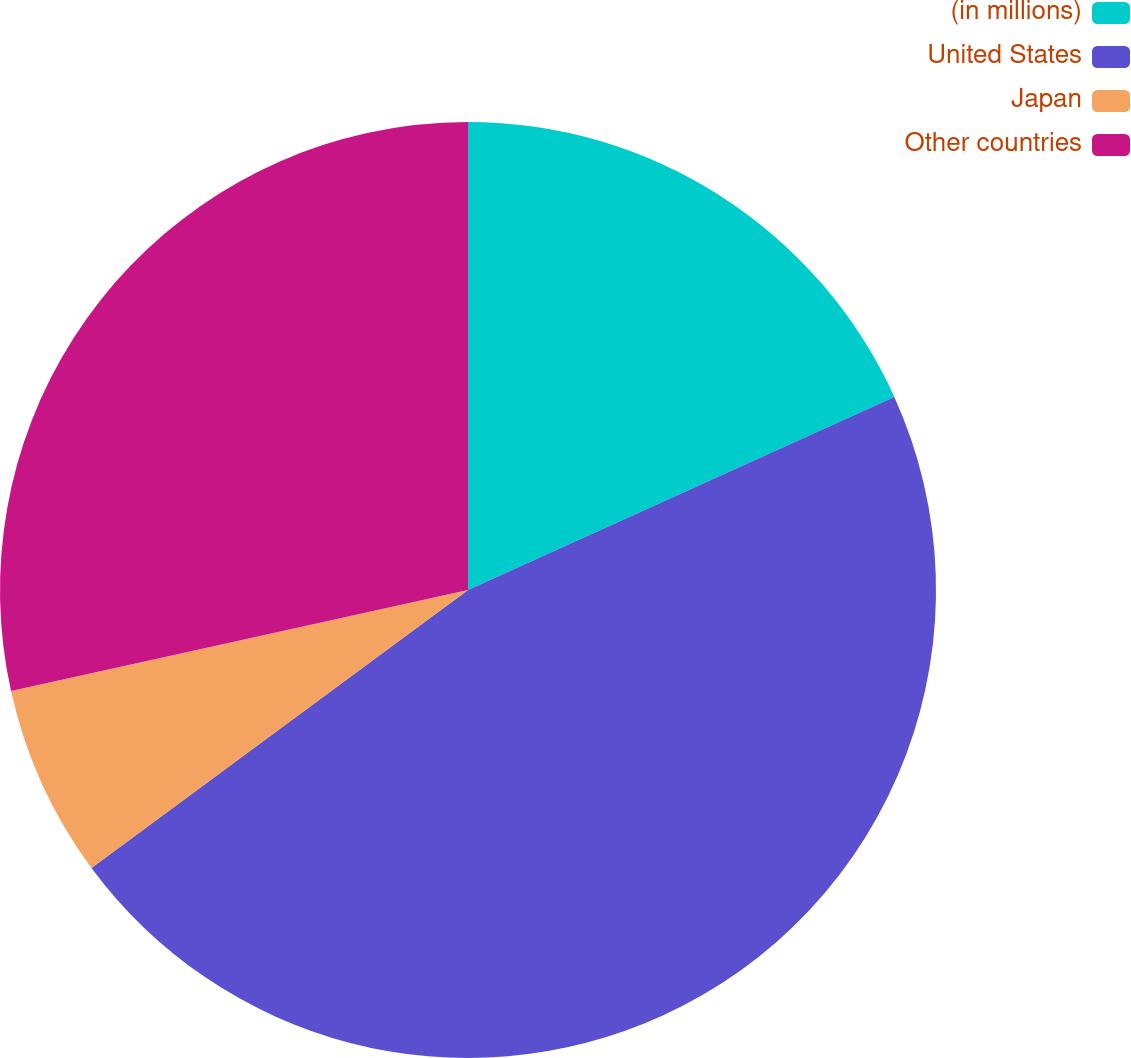<chart> <loc_0><loc_0><loc_500><loc_500><pie_chart><fcel>(in millions)<fcel>United States<fcel>Japan<fcel>Other countries<nl><fcel>18.23%<fcel>46.65%<fcel>6.66%<fcel>28.46%<nl></chart> 